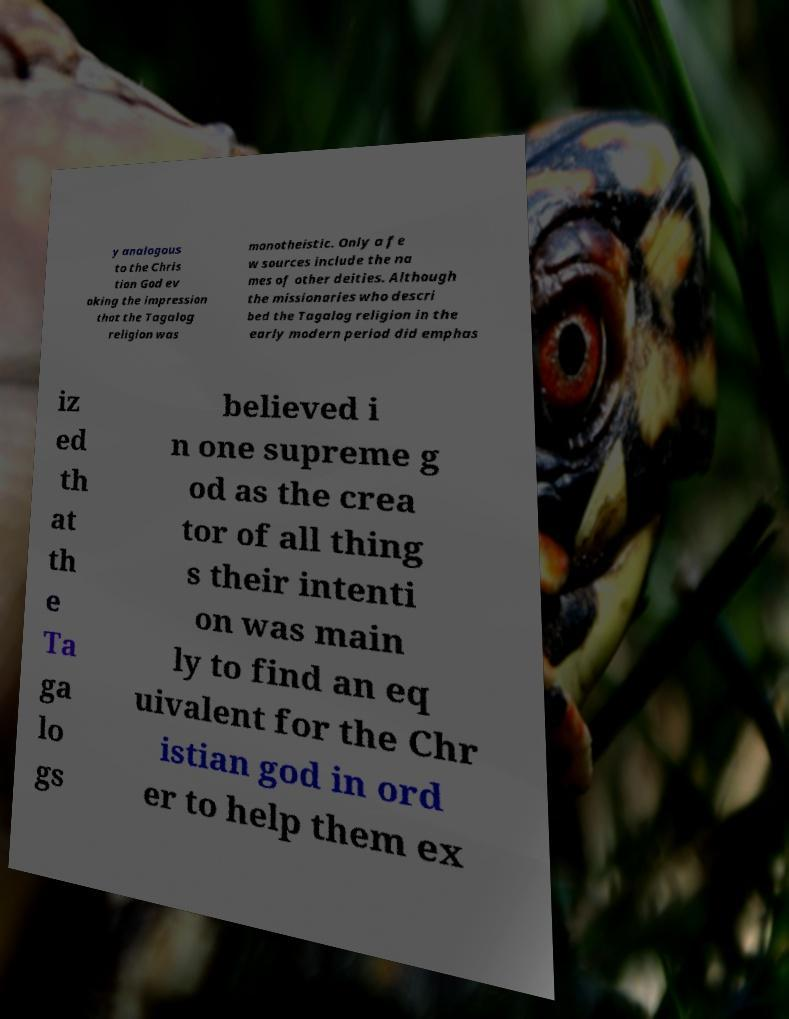Can you read and provide the text displayed in the image?This photo seems to have some interesting text. Can you extract and type it out for me? y analogous to the Chris tian God ev oking the impression that the Tagalog religion was monotheistic. Only a fe w sources include the na mes of other deities. Although the missionaries who descri bed the Tagalog religion in the early modern period did emphas iz ed th at th e Ta ga lo gs believed i n one supreme g od as the crea tor of all thing s their intenti on was main ly to find an eq uivalent for the Chr istian god in ord er to help them ex 